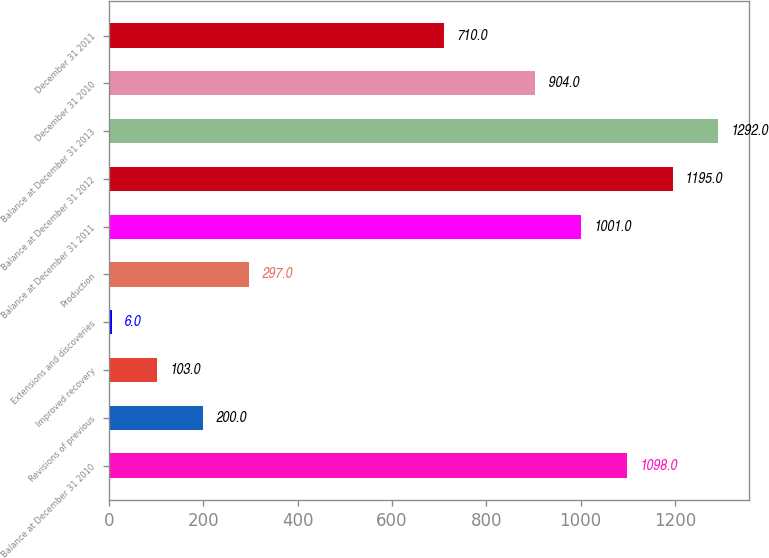Convert chart. <chart><loc_0><loc_0><loc_500><loc_500><bar_chart><fcel>Balance at December 31 2010<fcel>Revisions of previous<fcel>Improved recovery<fcel>Extensions and discoveries<fcel>Production<fcel>Balance at December 31 2011<fcel>Balance at December 31 2012<fcel>Balance at December 31 2013<fcel>December 31 2010<fcel>December 31 2011<nl><fcel>1098<fcel>200<fcel>103<fcel>6<fcel>297<fcel>1001<fcel>1195<fcel>1292<fcel>904<fcel>710<nl></chart> 